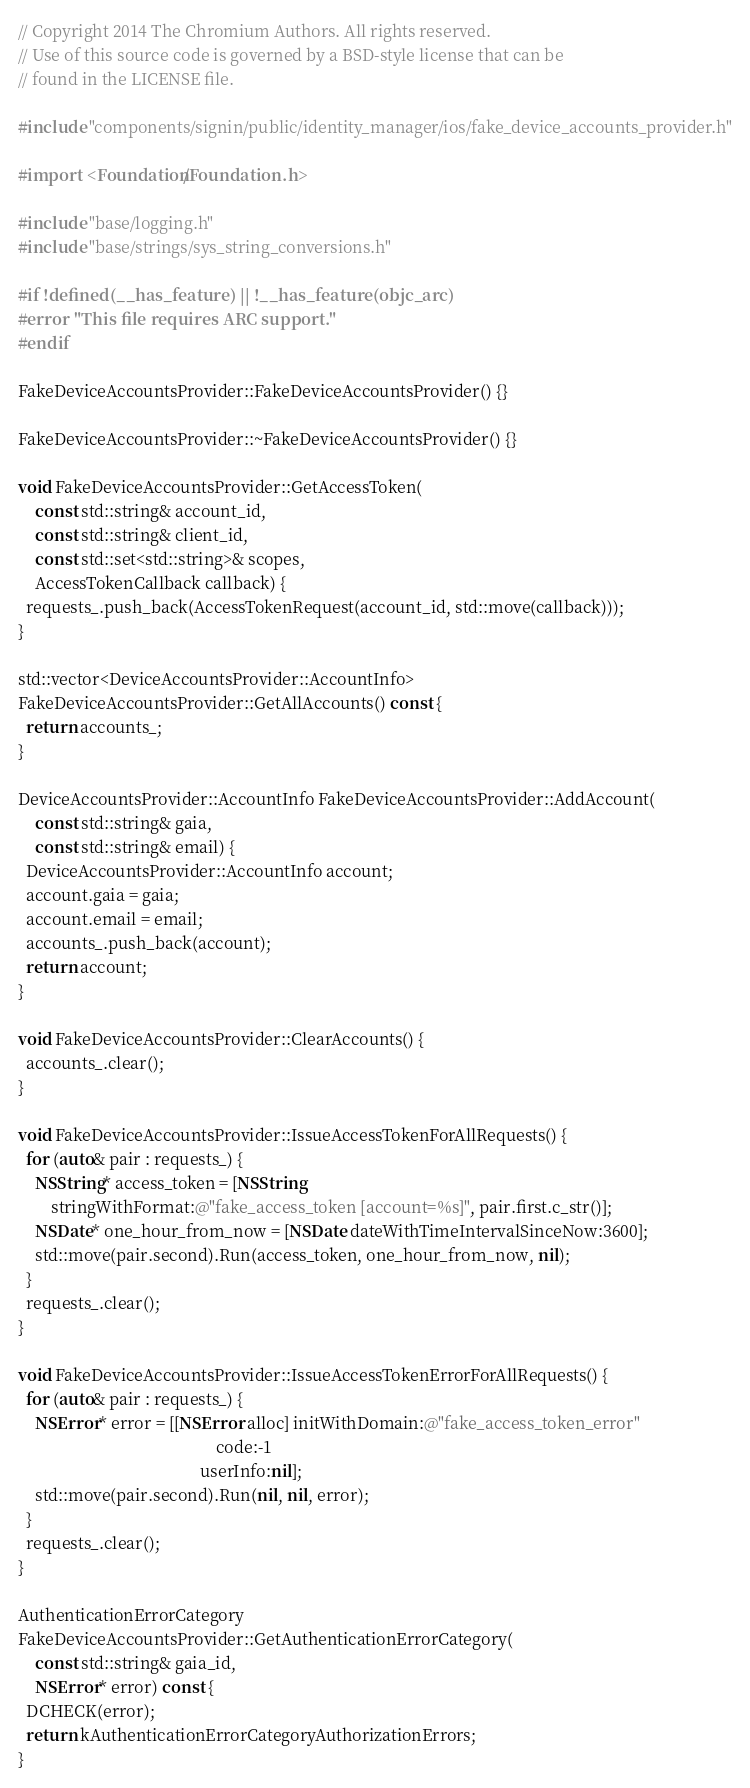<code> <loc_0><loc_0><loc_500><loc_500><_ObjectiveC_>// Copyright 2014 The Chromium Authors. All rights reserved.
// Use of this source code is governed by a BSD-style license that can be
// found in the LICENSE file.

#include "components/signin/public/identity_manager/ios/fake_device_accounts_provider.h"

#import <Foundation/Foundation.h>

#include "base/logging.h"
#include "base/strings/sys_string_conversions.h"

#if !defined(__has_feature) || !__has_feature(objc_arc)
#error "This file requires ARC support."
#endif

FakeDeviceAccountsProvider::FakeDeviceAccountsProvider() {}

FakeDeviceAccountsProvider::~FakeDeviceAccountsProvider() {}

void FakeDeviceAccountsProvider::GetAccessToken(
    const std::string& account_id,
    const std::string& client_id,
    const std::set<std::string>& scopes,
    AccessTokenCallback callback) {
  requests_.push_back(AccessTokenRequest(account_id, std::move(callback)));
}

std::vector<DeviceAccountsProvider::AccountInfo>
FakeDeviceAccountsProvider::GetAllAccounts() const {
  return accounts_;
}

DeviceAccountsProvider::AccountInfo FakeDeviceAccountsProvider::AddAccount(
    const std::string& gaia,
    const std::string& email) {
  DeviceAccountsProvider::AccountInfo account;
  account.gaia = gaia;
  account.email = email;
  accounts_.push_back(account);
  return account;
}

void FakeDeviceAccountsProvider::ClearAccounts() {
  accounts_.clear();
}

void FakeDeviceAccountsProvider::IssueAccessTokenForAllRequests() {
  for (auto& pair : requests_) {
    NSString* access_token = [NSString
        stringWithFormat:@"fake_access_token [account=%s]", pair.first.c_str()];
    NSDate* one_hour_from_now = [NSDate dateWithTimeIntervalSinceNow:3600];
    std::move(pair.second).Run(access_token, one_hour_from_now, nil);
  }
  requests_.clear();
}

void FakeDeviceAccountsProvider::IssueAccessTokenErrorForAllRequests() {
  for (auto& pair : requests_) {
    NSError* error = [[NSError alloc] initWithDomain:@"fake_access_token_error"
                                                code:-1
                                            userInfo:nil];
    std::move(pair.second).Run(nil, nil, error);
  }
  requests_.clear();
}

AuthenticationErrorCategory
FakeDeviceAccountsProvider::GetAuthenticationErrorCategory(
    const std::string& gaia_id,
    NSError* error) const {
  DCHECK(error);
  return kAuthenticationErrorCategoryAuthorizationErrors;
}
</code> 